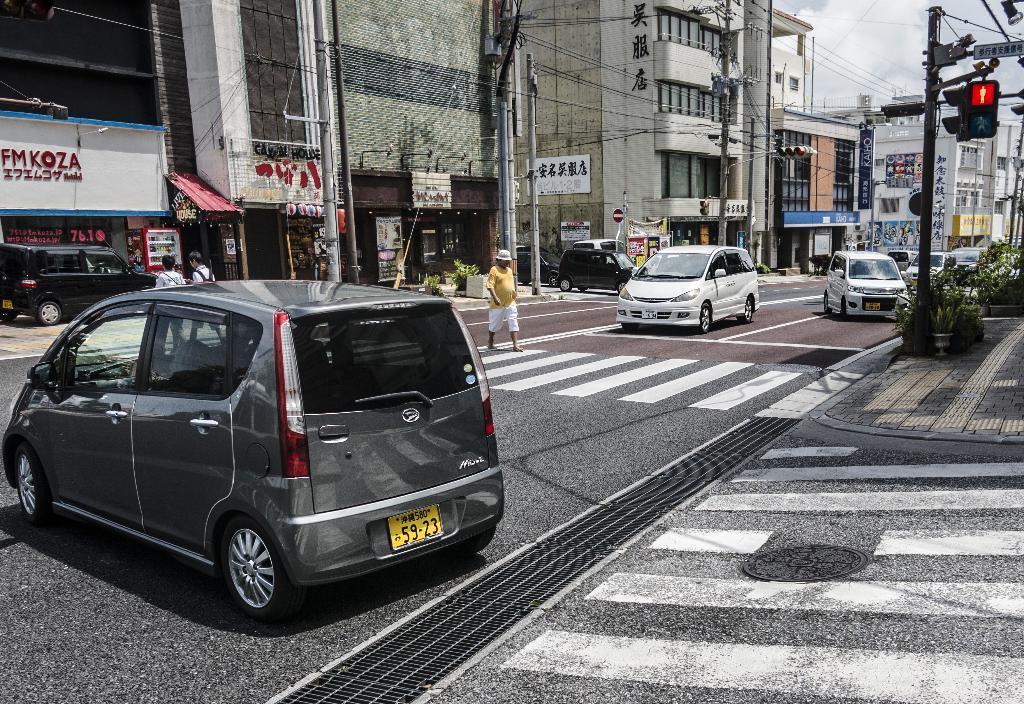Describe this image in one or two sentences. In this image we can see vehicles on the road. There are people walking. In the background of the image there are buildings, poles. At the top of the image there is sky. To the right side of the image there are plants. 